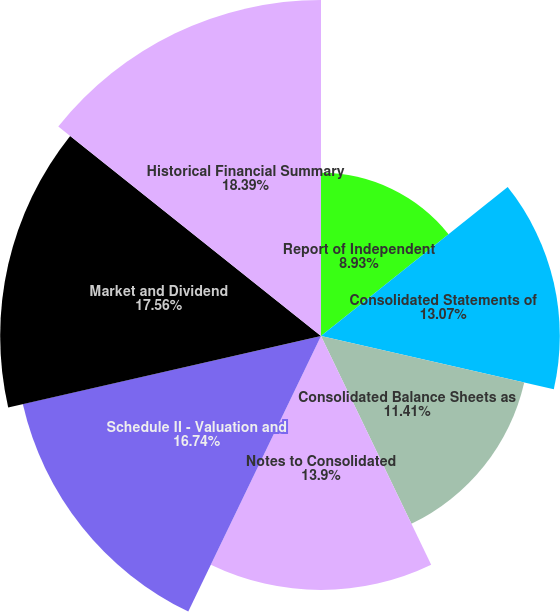Convert chart. <chart><loc_0><loc_0><loc_500><loc_500><pie_chart><fcel>Report of Independent<fcel>Consolidated Statements of<fcel>Consolidated Balance Sheets as<fcel>Notes to Consolidated<fcel>Schedule II - Valuation and<fcel>Market and Dividend<fcel>Historical Financial Summary<nl><fcel>8.93%<fcel>13.07%<fcel>11.41%<fcel>13.9%<fcel>16.74%<fcel>17.56%<fcel>18.39%<nl></chart> 